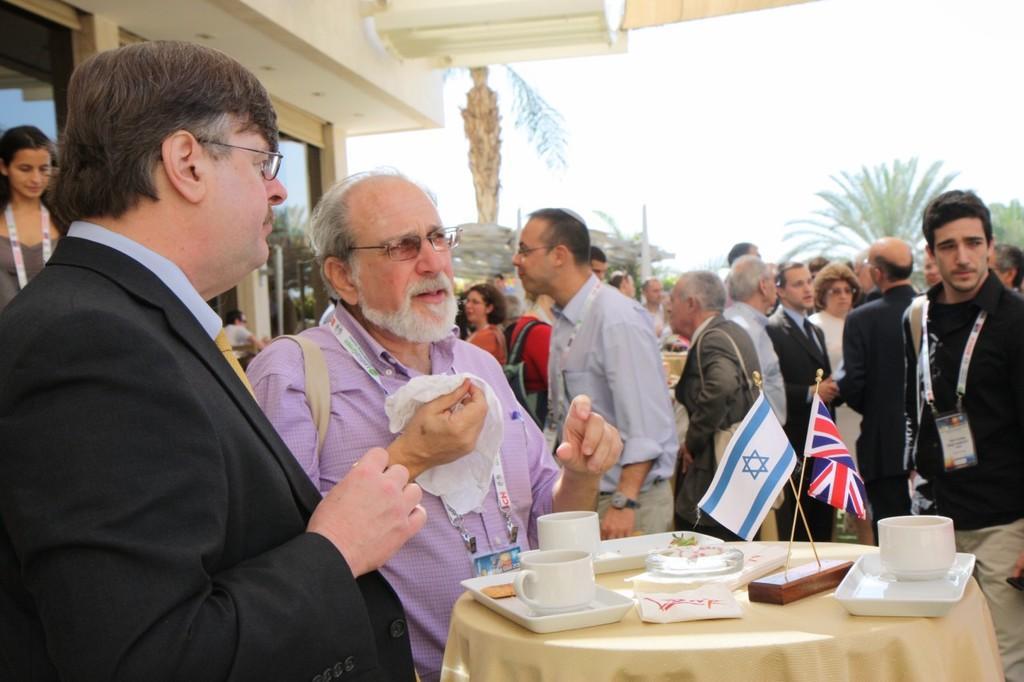Could you give a brief overview of what you see in this image? In the foreground of this image, there is a table on which there are cups, trays, tissues and flags. On the left, there are two men standing, where a man is holding a kerchief and wearing a bag. In the background, there are people standing wearing bags and ID tags. We can also see few trees and sky in the background and on the left top, it seems like a building. 